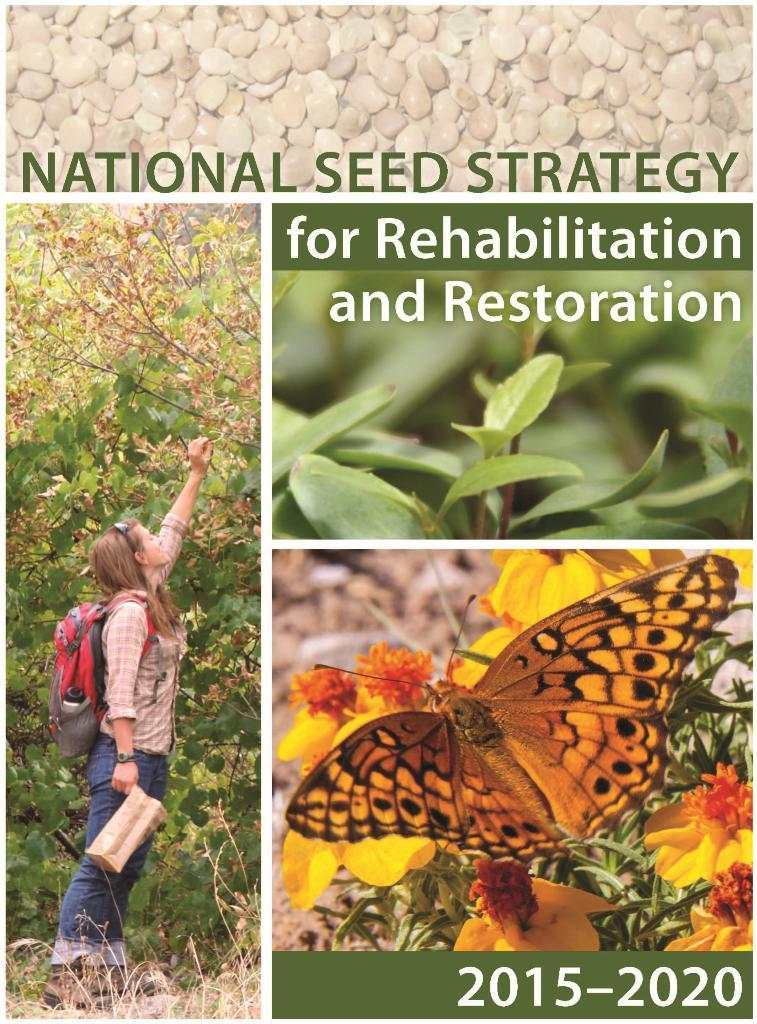What is the main subject of the image? There is a woman standing in the image. Where is the woman standing? The woman is standing on the ground. What else can be seen in the image besides the woman? There are plants in the image. Can you describe the plants in the image? A butterfly is present on the plants. Reasoning: Let's think step by following the guidelines to produce the conversation. We start by identifying the main subject of the image, which is the woman standing. Then, we describe her location, which is on the ground. Next, we mention the presence of plants in the image. Finally, we provide a specific detail about the plants, which is the presence of a butterfly. Each question is designed to elicit a specific detail about the image that is known from the provided facts. Absurd Question/Answer: What type of boat can be seen in the image? There is no boat present in the image. What type of attraction can be seen in the image? There is no attraction present in the image. 